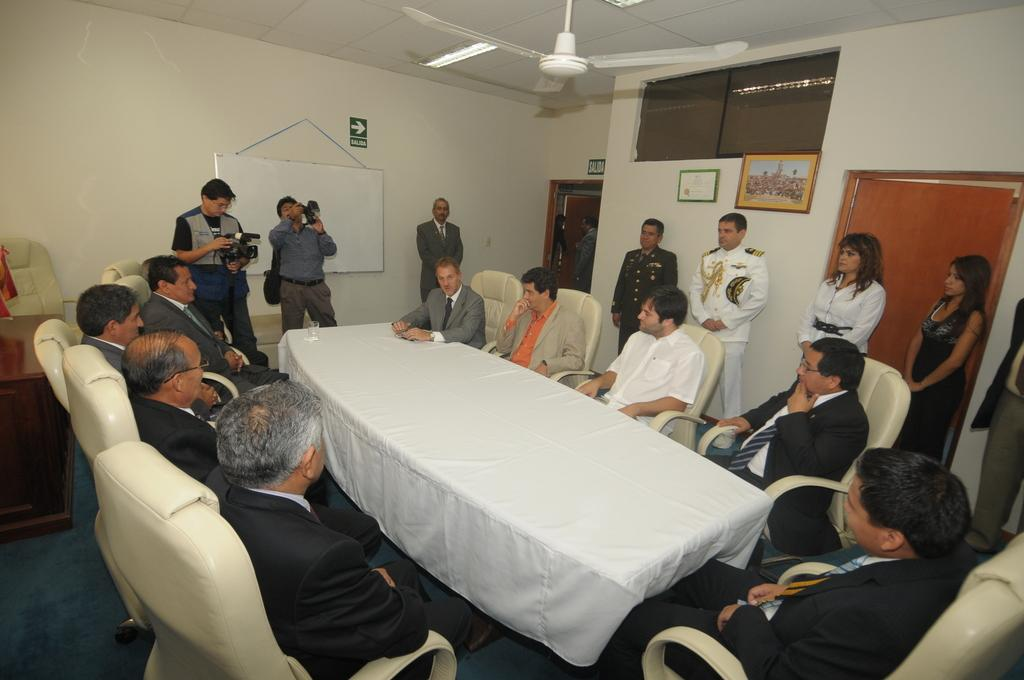What is the main activity of the people in the image? The main activity of the people in the image is sitting around a table. What type of clothing are many of the people wearing? Many of the people are wearing coats, ties, or shirts. Can you describe the people standing in the image? Two women are standing on the right side. What can be seen at the top of the image? There is a fan in white color at the top of the image. How many friends are laughing together in the image? There is no information about friends or laughter in the image. The image shows a group of people sitting around a table, but it does not specify if they are friends or if they are laughing. 